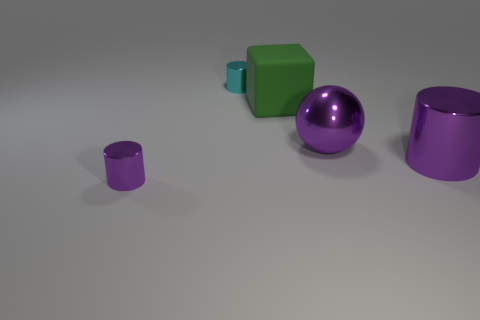Is there any other thing that is made of the same material as the big green object?
Provide a short and direct response. No. How big is the metallic cylinder that is left of the green matte thing and right of the small purple shiny cylinder?
Provide a short and direct response. Small. What shape is the small shiny thing that is on the right side of the tiny metallic object that is in front of the big green matte cube?
Your response must be concise. Cylinder. Is there anything else that has the same color as the ball?
Ensure brevity in your answer.  Yes. What shape is the big thing that is behind the large purple ball?
Your response must be concise. Cube. There is a metallic object that is both to the left of the big green rubber cube and behind the large purple cylinder; what is its shape?
Ensure brevity in your answer.  Cylinder. How many purple things are either big matte things or metal things?
Your response must be concise. 3. Is the color of the shiny cylinder to the left of the small cyan metallic thing the same as the large cylinder?
Keep it short and to the point. Yes. There is a green matte object right of the tiny metallic thing that is in front of the large shiny sphere; how big is it?
Offer a terse response. Large. What is the material of the purple cylinder that is the same size as the rubber object?
Offer a terse response. Metal. 